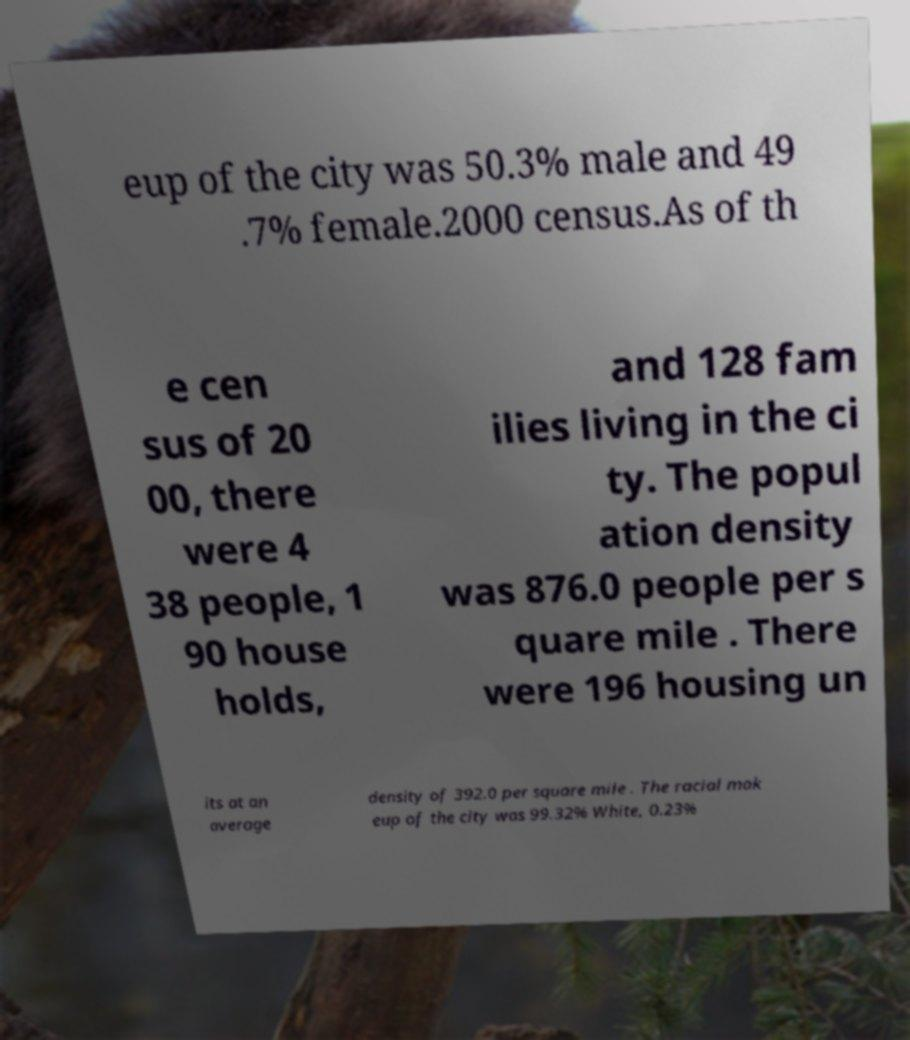Can you read and provide the text displayed in the image?This photo seems to have some interesting text. Can you extract and type it out for me? eup of the city was 50.3% male and 49 .7% female.2000 census.As of th e cen sus of 20 00, there were 4 38 people, 1 90 house holds, and 128 fam ilies living in the ci ty. The popul ation density was 876.0 people per s quare mile . There were 196 housing un its at an average density of 392.0 per square mile . The racial mak eup of the city was 99.32% White, 0.23% 